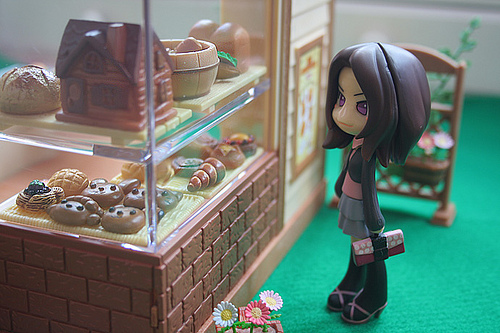<image>
Is there a flower next to the bowl? No. The flower is not positioned next to the bowl. They are located in different areas of the scene. Is the miniature house in front of the miniature girl? Yes. The miniature house is positioned in front of the miniature girl, appearing closer to the camera viewpoint. 